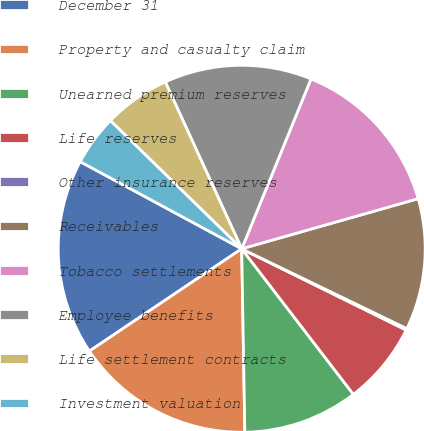Convert chart. <chart><loc_0><loc_0><loc_500><loc_500><pie_chart><fcel>December 31<fcel>Property and casualty claim<fcel>Unearned premium reserves<fcel>Life reserves<fcel>Other insurance reserves<fcel>Receivables<fcel>Tobacco settlements<fcel>Employee benefits<fcel>Life settlement contracts<fcel>Investment valuation<nl><fcel>17.29%<fcel>15.86%<fcel>10.14%<fcel>7.28%<fcel>0.14%<fcel>11.57%<fcel>14.43%<fcel>13.0%<fcel>5.86%<fcel>4.43%<nl></chart> 